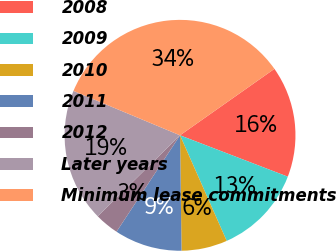Convert chart to OTSL. <chart><loc_0><loc_0><loc_500><loc_500><pie_chart><fcel>2008<fcel>2009<fcel>2010<fcel>2011<fcel>2012<fcel>Later years<fcel>Minimum lease commitments<nl><fcel>15.6%<fcel>12.54%<fcel>6.42%<fcel>9.48%<fcel>3.36%<fcel>18.66%<fcel>33.96%<nl></chart> 